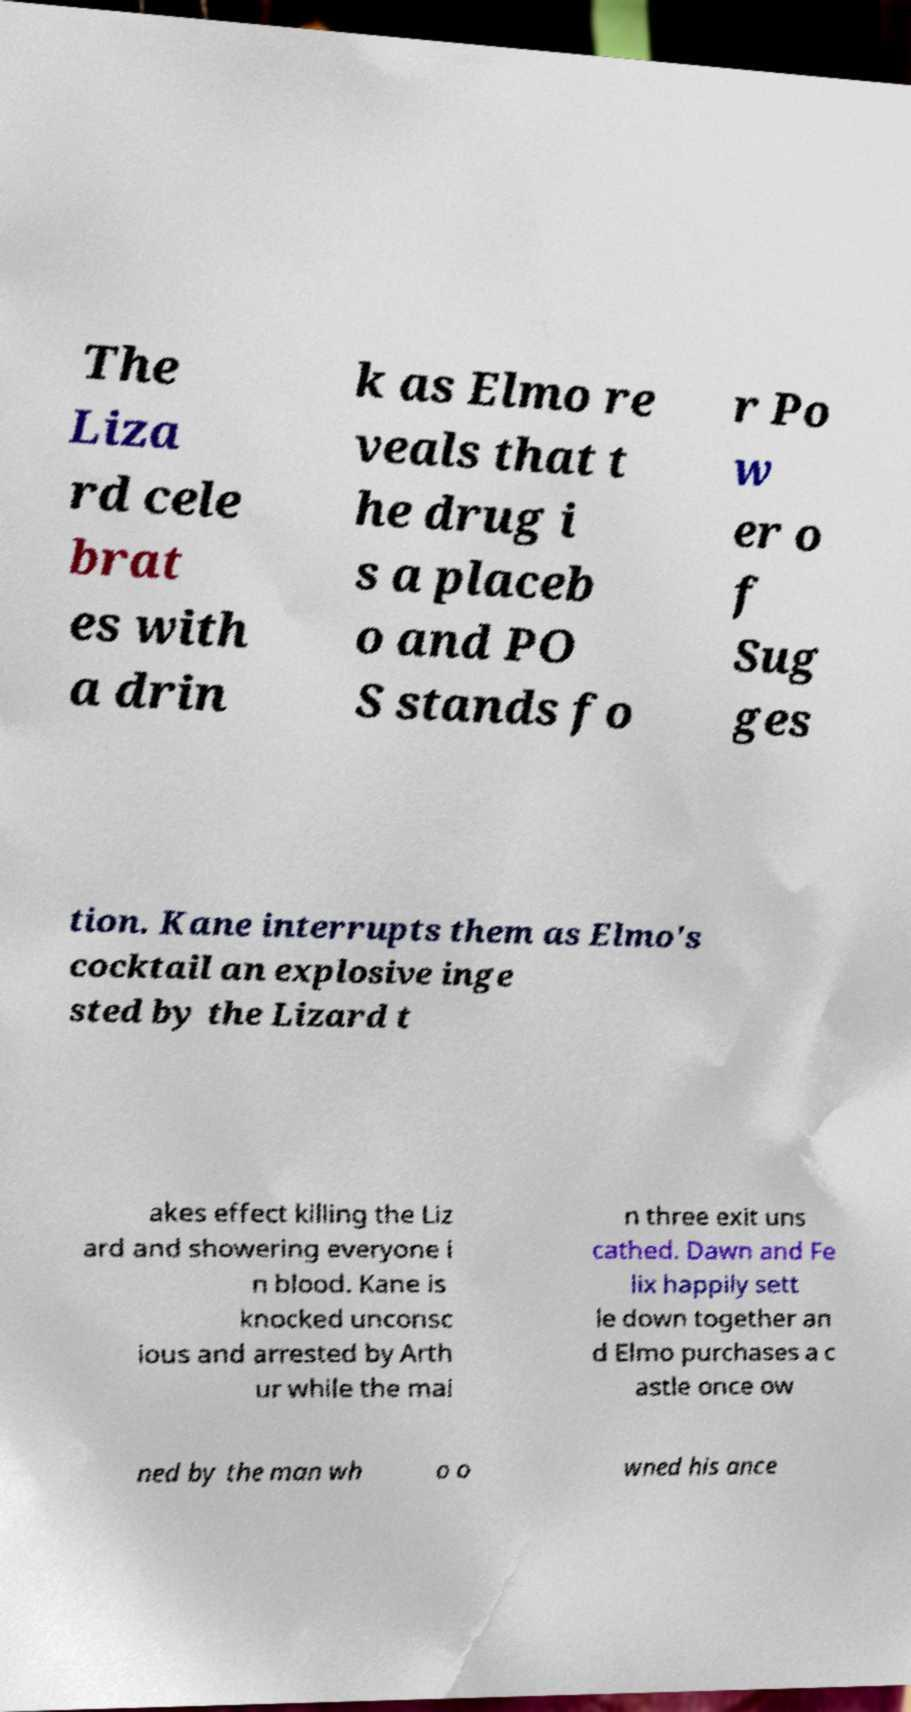What messages or text are displayed in this image? I need them in a readable, typed format. The Liza rd cele brat es with a drin k as Elmo re veals that t he drug i s a placeb o and PO S stands fo r Po w er o f Sug ges tion. Kane interrupts them as Elmo's cocktail an explosive inge sted by the Lizard t akes effect killing the Liz ard and showering everyone i n blood. Kane is knocked unconsc ious and arrested by Arth ur while the mai n three exit uns cathed. Dawn and Fe lix happily sett le down together an d Elmo purchases a c astle once ow ned by the man wh o o wned his ance 